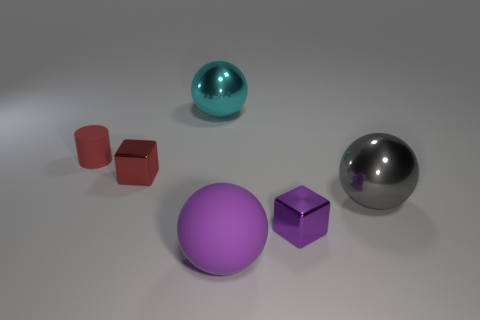What shape is the metallic object that is behind the red thing that is in front of the tiny matte thing?
Your answer should be very brief. Sphere. Is there anything else that has the same color as the matte cylinder?
Provide a short and direct response. Yes. Do the red matte cylinder and the object that is in front of the tiny purple thing have the same size?
Provide a short and direct response. No. What number of tiny things are either cyan balls or rubber cylinders?
Provide a succinct answer. 1. Are there more big shiny balls than tiny shiny cylinders?
Provide a succinct answer. Yes. What number of purple shiny cubes are to the left of the big shiny object behind the small shiny block that is behind the small purple shiny object?
Ensure brevity in your answer.  0. There is a tiny rubber thing; what shape is it?
Provide a succinct answer. Cylinder. What number of other things are there of the same material as the small red cube
Your response must be concise. 3. Does the red metallic thing have the same size as the cylinder?
Provide a short and direct response. Yes. There is a tiny metallic object that is left of the large purple rubber sphere; what shape is it?
Your answer should be very brief. Cube. 